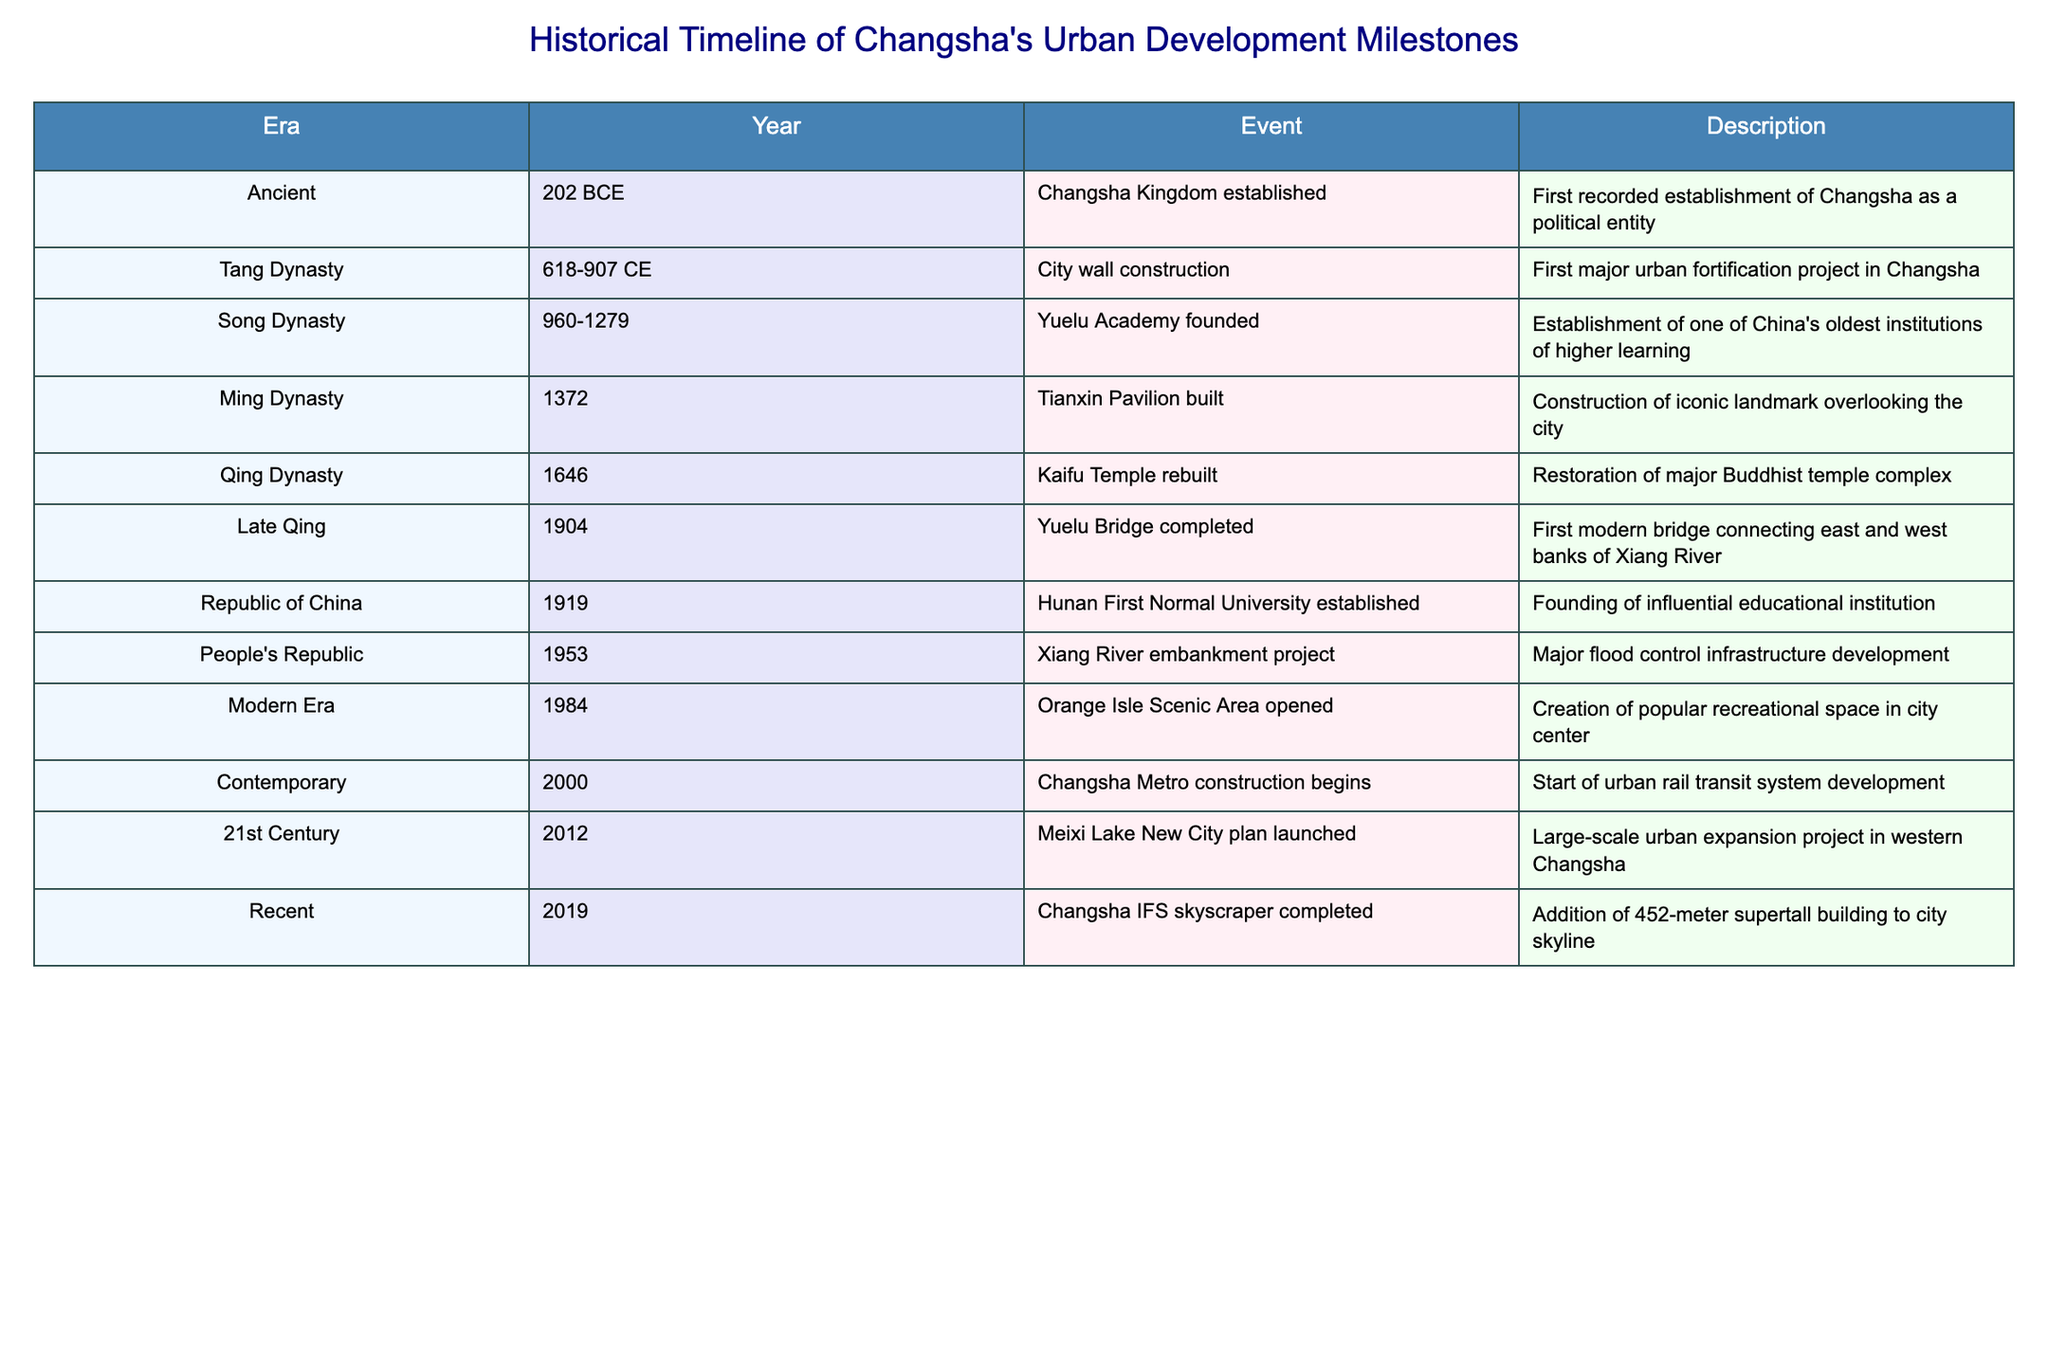What year was the Changsha Kingdom established? The table lists the event "Changsha Kingdom established" under the Ancient era with the corresponding year as 202 BCE.
Answer: 202 BCE What significant educational institution was founded in 1919? The table states that "Hunan First Normal University established" was the event that occurred in 1919, marking the founding of an influential educational institution.
Answer: Hunan First Normal University How many major urban development milestones are recorded in the table? By counting each of the events listed in the table, there are 10 milestones recorded in total.
Answer: 10 What was the first major urban fortification project in Changsha's history? According to the table, the "City wall construction" during the Tang Dynasty is marked as the first major urban fortification project in Changsha.
Answer: City wall construction In what era was the Kaifu Temple rebuilt? The table indicates that the reconstruction of the Kaifu Temple took place during the Qing Dynasty in the year 1646.
Answer: Qing Dynasty Which event occurred just before the establishment of the Changsha Metro construction? The table shows that the "Orange Isle Scenic Area opened" in 1984 occurred before the "Changsha Metro construction begins" in 2000.
Answer: Orange Isle Scenic Area opened Was the Yuelu Academy founded before or after the Tianxin Pavilion was built? Referring to the table, Yuelu Academy was founded during the Song Dynasty (960-1279) and Tianxin Pavilion was built in 1372 during the Ming Dynasty, indicating that the academy was founded before the pavilion.
Answer: Before How many years passed between the completion of the Yuelu Bridge in 1904 and the establishment of the Hunan First Normal University in 1919? To find the difference, subtract the year of the Yuelu Bridge completion (1904) from the year of the university's establishment (1919): 1919 - 1904 = 15 years.
Answer: 15 years Which event marks the modern era in Changsha's urban development timeline? The opening of the Orange Isle Scenic Area in 1984 is noted in the table as the event that marks the beginning of the modern era.
Answer: Orange Isle Scenic Area opened In which decade did the major flood control infrastructure development take place? The Xiang River embankment project was completed in 1953, which falls in the 1950s decade.
Answer: 1950s Which two events related to architecture occurred in the Ming Dynasty? The table lists two events during the Ming Dynasty: the "Tianxin Pavilion built" in 1372 and the "City wall construction" which appears earlier in the table but is not directly tied to this dynasty. Therefore, only the Tianxin Pavilion can be directly linked to this dynasty in the timeline.
Answer: Tianxin Pavilion built How many decades apart are the events of the Meixi Lake New City plan launched and the construction of the Changsha Metro? The Meixi Lake New City plan launched in 2012 and the Changsha Metro construction began in 2000. This is a difference of 12 years or roughly 1 decade apart.
Answer: 1 decade What was the tallest building in Changsha upon completion in 2019? The table notes that "Changsha IFS skyscraper completed" in 2019, which is the tallest building mentioned in the table at 452 meters.
Answer: Changsha IFS skyscraper 